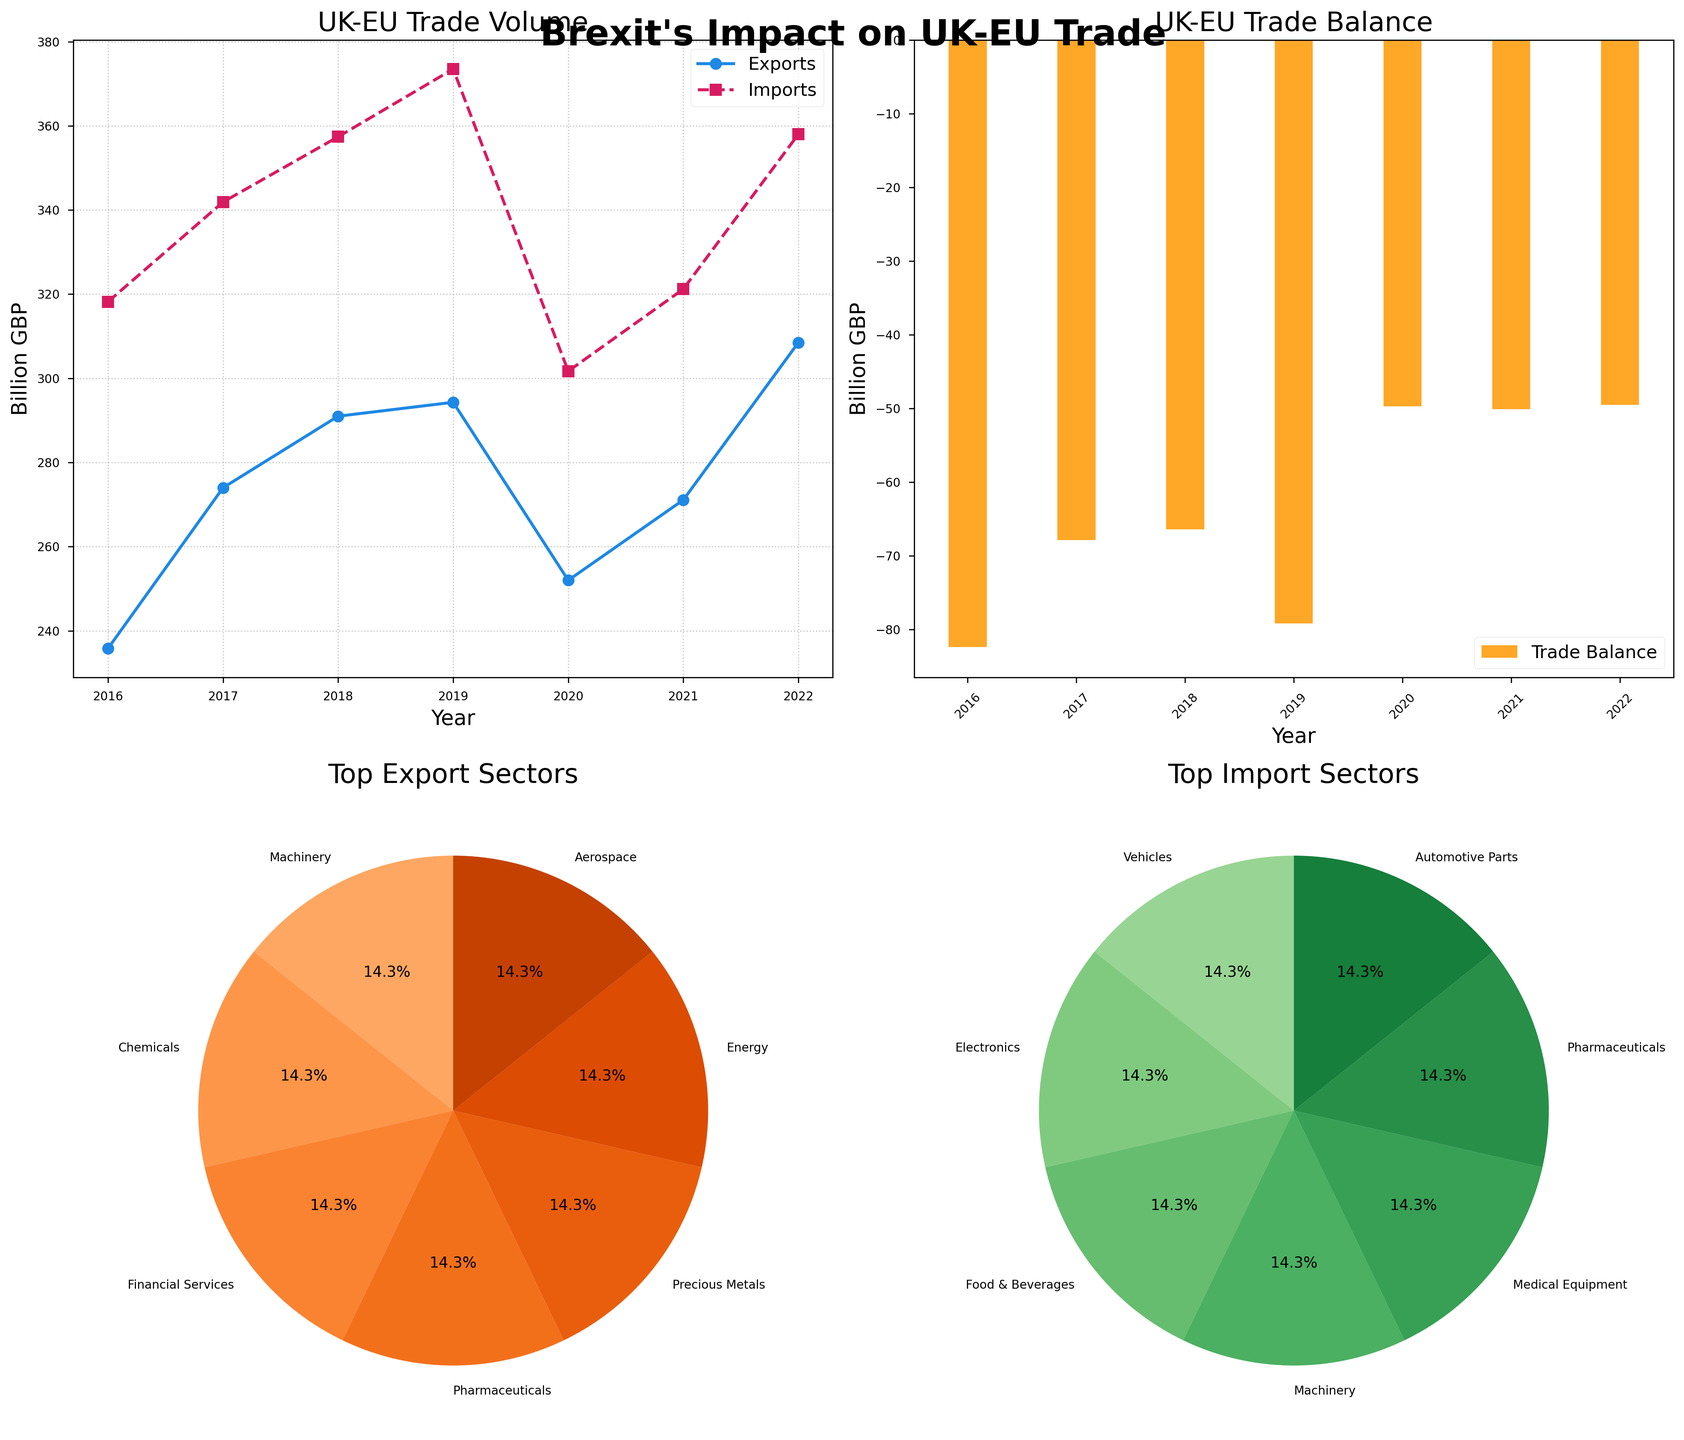What is the title of the first subplot? The title of the first subplot is displayed at the top of that subplot within the figure.
Answer: UK-EU Trade Volume How many years of data are presented in the bar plot? Count the number of distinct bars on the bar plot to determine the number of years represented.
Answer: 7 Which year had the highest trade balance deficit? Look at the bar plot and find the bar that extends the furthest below the zero line, which represents the year with the highest trade balance deficit.
Answer: 2016 Are there more top export sectors or top import sectors? Compare the number of segments in the two pie charts: one for top export sectors and one for top import sectors.
Answer: Equal What are the top export and import sectors for 2020? Identify the specific columns for 2020 and check the corresponding values for the top export and import sectors.
Answer: Precious Metals, Medical Equipment In which year did the UK experience the smallest trade balance deficit? From the bar plot, find the bar that is nearest to the zero line but still below it, representing the year with the smallest trade balance deficit.
Answer: 2022 By how much did UK exports to the EU increase from 2020 to 2022? Look at the line plot, note the export values for 2020 and 2022, and calculate the difference. Exports in 2020 were 252.0 billion GBP, and in 2022 were 308.5 billion GBP, so the increase is 308.5 - 252.0.
Answer: 56.5 billion GBP Which year showed a trade balance value closest to -50 billion GBP? On the bar plot, find the bar that is closest to the -50 billion GBP mark.
Answer: 2021 Between which two consecutive years did UK imports from the EU show the greatest increase? From the line plot, compare the import values for consecutive years, finding the pair with the largest increase.
Answer: 2016-2017 What percentage of the top export sectors is represented by the most frequent sector? In the pie chart of top export sectors, find the sector with the largest slice and note the percentage labeled for that slice.
Answer: 14.3% 